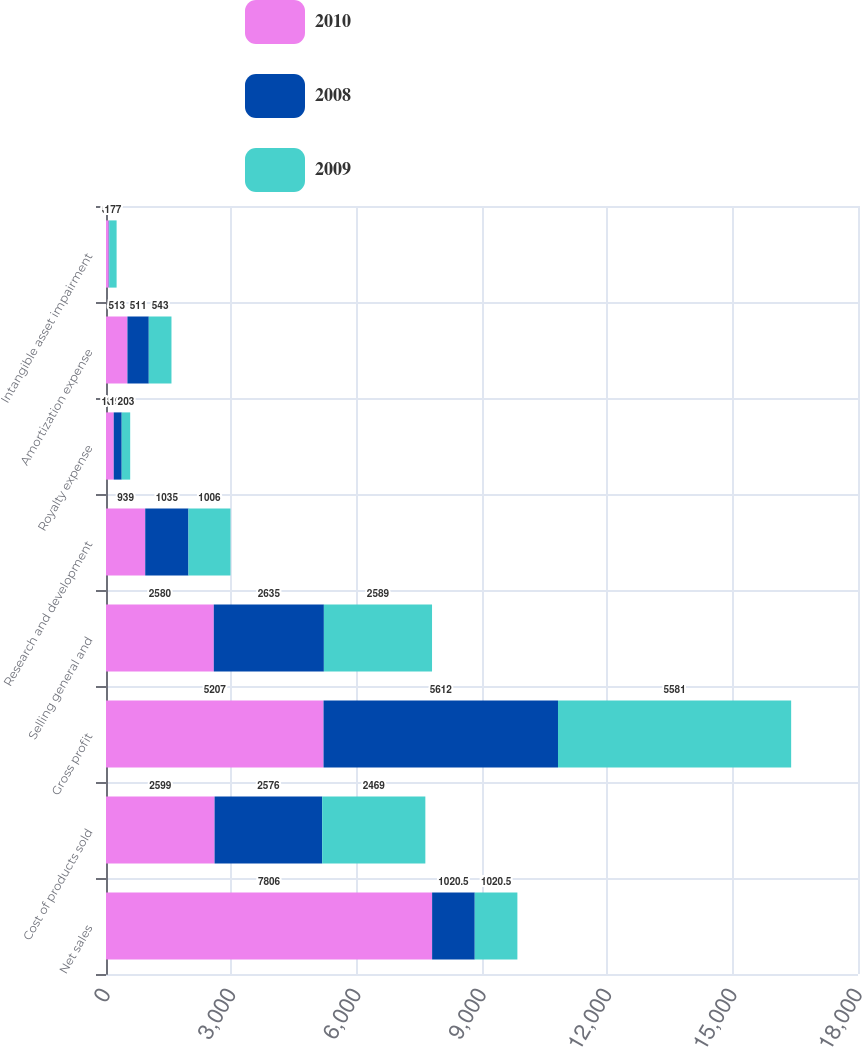<chart> <loc_0><loc_0><loc_500><loc_500><stacked_bar_chart><ecel><fcel>Net sales<fcel>Cost of products sold<fcel>Gross profit<fcel>Selling general and<fcel>Research and development<fcel>Royalty expense<fcel>Amortization expense<fcel>Intangible asset impairment<nl><fcel>2010<fcel>7806<fcel>2599<fcel>5207<fcel>2580<fcel>939<fcel>185<fcel>513<fcel>65<nl><fcel>2008<fcel>1020.5<fcel>2576<fcel>5612<fcel>2635<fcel>1035<fcel>191<fcel>511<fcel>12<nl><fcel>2009<fcel>1020.5<fcel>2469<fcel>5581<fcel>2589<fcel>1006<fcel>203<fcel>543<fcel>177<nl></chart> 